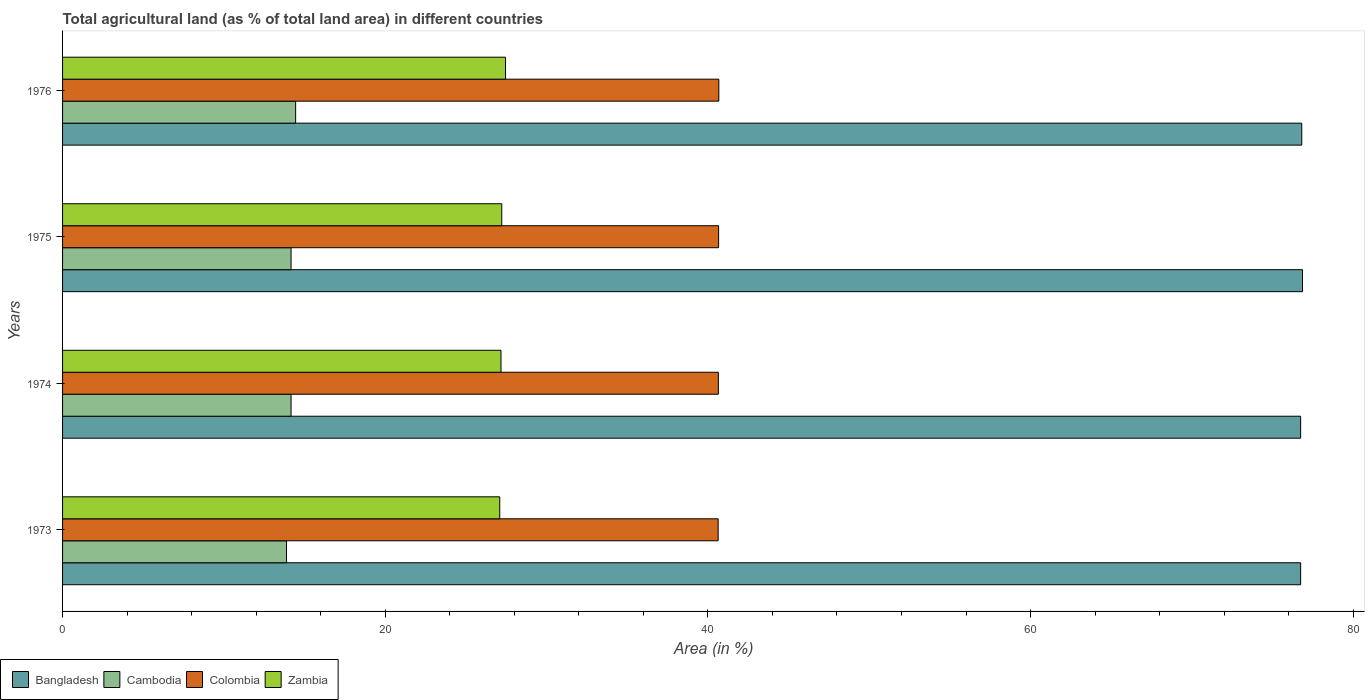Are the number of bars per tick equal to the number of legend labels?
Keep it short and to the point. Yes. What is the label of the 1st group of bars from the top?
Give a very brief answer. 1976. What is the percentage of agricultural land in Bangladesh in 1973?
Offer a very short reply. 76.74. Across all years, what is the maximum percentage of agricultural land in Cambodia?
Your answer should be compact. 14.45. Across all years, what is the minimum percentage of agricultural land in Zambia?
Provide a succinct answer. 27.1. In which year was the percentage of agricultural land in Bangladesh maximum?
Your answer should be compact. 1975. In which year was the percentage of agricultural land in Colombia minimum?
Your answer should be very brief. 1973. What is the total percentage of agricultural land in Zambia in the graph?
Provide a succinct answer. 108.95. What is the difference between the percentage of agricultural land in Cambodia in 1975 and that in 1976?
Provide a succinct answer. -0.28. What is the difference between the percentage of agricultural land in Cambodia in 1976 and the percentage of agricultural land in Colombia in 1974?
Provide a short and direct response. -26.2. What is the average percentage of agricultural land in Colombia per year?
Provide a short and direct response. 40.66. In the year 1976, what is the difference between the percentage of agricultural land in Cambodia and percentage of agricultural land in Bangladesh?
Your response must be concise. -62.36. What is the ratio of the percentage of agricultural land in Zambia in 1973 to that in 1976?
Provide a short and direct response. 0.99. Is the percentage of agricultural land in Colombia in 1974 less than that in 1976?
Ensure brevity in your answer.  Yes. Is the difference between the percentage of agricultural land in Cambodia in 1973 and 1974 greater than the difference between the percentage of agricultural land in Bangladesh in 1973 and 1974?
Provide a short and direct response. No. What is the difference between the highest and the second highest percentage of agricultural land in Cambodia?
Offer a very short reply. 0.28. What is the difference between the highest and the lowest percentage of agricultural land in Bangladesh?
Make the answer very short. 0.12. In how many years, is the percentage of agricultural land in Zambia greater than the average percentage of agricultural land in Zambia taken over all years?
Provide a short and direct response. 1. Is it the case that in every year, the sum of the percentage of agricultural land in Cambodia and percentage of agricultural land in Zambia is greater than the sum of percentage of agricultural land in Colombia and percentage of agricultural land in Bangladesh?
Give a very brief answer. No. What does the 2nd bar from the bottom in 1974 represents?
Offer a very short reply. Cambodia. How many bars are there?
Make the answer very short. 16. Are the values on the major ticks of X-axis written in scientific E-notation?
Give a very brief answer. No. Does the graph contain grids?
Your answer should be compact. No. Where does the legend appear in the graph?
Provide a succinct answer. Bottom left. How many legend labels are there?
Offer a very short reply. 4. What is the title of the graph?
Provide a succinct answer. Total agricultural land (as % of total land area) in different countries. Does "Germany" appear as one of the legend labels in the graph?
Provide a succinct answer. No. What is the label or title of the X-axis?
Your response must be concise. Area (in %). What is the label or title of the Y-axis?
Offer a very short reply. Years. What is the Area (in %) in Bangladesh in 1973?
Ensure brevity in your answer.  76.74. What is the Area (in %) in Cambodia in 1973?
Provide a short and direct response. 13.88. What is the Area (in %) in Colombia in 1973?
Make the answer very short. 40.63. What is the Area (in %) in Zambia in 1973?
Your answer should be compact. 27.1. What is the Area (in %) in Bangladesh in 1974?
Your answer should be very brief. 76.74. What is the Area (in %) in Cambodia in 1974?
Keep it short and to the point. 14.16. What is the Area (in %) in Colombia in 1974?
Make the answer very short. 40.65. What is the Area (in %) of Zambia in 1974?
Your answer should be compact. 27.18. What is the Area (in %) in Bangladesh in 1975?
Offer a very short reply. 76.85. What is the Area (in %) of Cambodia in 1975?
Keep it short and to the point. 14.16. What is the Area (in %) of Colombia in 1975?
Ensure brevity in your answer.  40.66. What is the Area (in %) of Zambia in 1975?
Offer a terse response. 27.22. What is the Area (in %) in Bangladesh in 1976?
Provide a short and direct response. 76.81. What is the Area (in %) of Cambodia in 1976?
Offer a very short reply. 14.45. What is the Area (in %) of Colombia in 1976?
Offer a very short reply. 40.68. What is the Area (in %) of Zambia in 1976?
Make the answer very short. 27.46. Across all years, what is the maximum Area (in %) in Bangladesh?
Offer a very short reply. 76.85. Across all years, what is the maximum Area (in %) of Cambodia?
Your answer should be very brief. 14.45. Across all years, what is the maximum Area (in %) of Colombia?
Your answer should be compact. 40.68. Across all years, what is the maximum Area (in %) of Zambia?
Give a very brief answer. 27.46. Across all years, what is the minimum Area (in %) of Bangladesh?
Keep it short and to the point. 76.74. Across all years, what is the minimum Area (in %) of Cambodia?
Your answer should be compact. 13.88. Across all years, what is the minimum Area (in %) in Colombia?
Offer a very short reply. 40.63. Across all years, what is the minimum Area (in %) in Zambia?
Make the answer very short. 27.1. What is the total Area (in %) in Bangladesh in the graph?
Ensure brevity in your answer.  307.14. What is the total Area (in %) in Cambodia in the graph?
Your response must be concise. 56.65. What is the total Area (in %) of Colombia in the graph?
Ensure brevity in your answer.  162.62. What is the total Area (in %) in Zambia in the graph?
Offer a terse response. 108.95. What is the difference between the Area (in %) of Cambodia in 1973 and that in 1974?
Provide a short and direct response. -0.28. What is the difference between the Area (in %) in Colombia in 1973 and that in 1974?
Your answer should be very brief. -0.01. What is the difference between the Area (in %) in Zambia in 1973 and that in 1974?
Offer a very short reply. -0.08. What is the difference between the Area (in %) of Bangladesh in 1973 and that in 1975?
Offer a terse response. -0.12. What is the difference between the Area (in %) in Cambodia in 1973 and that in 1975?
Ensure brevity in your answer.  -0.28. What is the difference between the Area (in %) in Colombia in 1973 and that in 1975?
Provide a succinct answer. -0.03. What is the difference between the Area (in %) of Zambia in 1973 and that in 1975?
Your answer should be compact. -0.13. What is the difference between the Area (in %) of Bangladesh in 1973 and that in 1976?
Offer a terse response. -0.07. What is the difference between the Area (in %) in Cambodia in 1973 and that in 1976?
Ensure brevity in your answer.  -0.57. What is the difference between the Area (in %) of Colombia in 1973 and that in 1976?
Provide a succinct answer. -0.04. What is the difference between the Area (in %) in Zambia in 1973 and that in 1976?
Provide a short and direct response. -0.36. What is the difference between the Area (in %) in Bangladesh in 1974 and that in 1975?
Your response must be concise. -0.12. What is the difference between the Area (in %) in Cambodia in 1974 and that in 1975?
Keep it short and to the point. 0. What is the difference between the Area (in %) of Colombia in 1974 and that in 1975?
Offer a terse response. -0.01. What is the difference between the Area (in %) of Zambia in 1974 and that in 1975?
Offer a very short reply. -0.05. What is the difference between the Area (in %) of Bangladesh in 1974 and that in 1976?
Your answer should be compact. -0.07. What is the difference between the Area (in %) in Cambodia in 1974 and that in 1976?
Offer a terse response. -0.28. What is the difference between the Area (in %) in Colombia in 1974 and that in 1976?
Offer a very short reply. -0.03. What is the difference between the Area (in %) in Zambia in 1974 and that in 1976?
Make the answer very short. -0.28. What is the difference between the Area (in %) of Bangladesh in 1975 and that in 1976?
Make the answer very short. 0.05. What is the difference between the Area (in %) of Cambodia in 1975 and that in 1976?
Your answer should be compact. -0.28. What is the difference between the Area (in %) in Colombia in 1975 and that in 1976?
Your answer should be very brief. -0.01. What is the difference between the Area (in %) of Zambia in 1975 and that in 1976?
Your answer should be compact. -0.23. What is the difference between the Area (in %) of Bangladesh in 1973 and the Area (in %) of Cambodia in 1974?
Your response must be concise. 62.58. What is the difference between the Area (in %) of Bangladesh in 1973 and the Area (in %) of Colombia in 1974?
Provide a succinct answer. 36.09. What is the difference between the Area (in %) in Bangladesh in 1973 and the Area (in %) in Zambia in 1974?
Your answer should be very brief. 49.56. What is the difference between the Area (in %) in Cambodia in 1973 and the Area (in %) in Colombia in 1974?
Provide a succinct answer. -26.77. What is the difference between the Area (in %) of Cambodia in 1973 and the Area (in %) of Zambia in 1974?
Keep it short and to the point. -13.3. What is the difference between the Area (in %) in Colombia in 1973 and the Area (in %) in Zambia in 1974?
Provide a short and direct response. 13.46. What is the difference between the Area (in %) in Bangladesh in 1973 and the Area (in %) in Cambodia in 1975?
Make the answer very short. 62.58. What is the difference between the Area (in %) in Bangladesh in 1973 and the Area (in %) in Colombia in 1975?
Provide a short and direct response. 36.08. What is the difference between the Area (in %) of Bangladesh in 1973 and the Area (in %) of Zambia in 1975?
Ensure brevity in your answer.  49.52. What is the difference between the Area (in %) of Cambodia in 1973 and the Area (in %) of Colombia in 1975?
Make the answer very short. -26.78. What is the difference between the Area (in %) of Cambodia in 1973 and the Area (in %) of Zambia in 1975?
Your answer should be very brief. -13.34. What is the difference between the Area (in %) of Colombia in 1973 and the Area (in %) of Zambia in 1975?
Make the answer very short. 13.41. What is the difference between the Area (in %) in Bangladesh in 1973 and the Area (in %) in Cambodia in 1976?
Give a very brief answer. 62.29. What is the difference between the Area (in %) in Bangladesh in 1973 and the Area (in %) in Colombia in 1976?
Provide a short and direct response. 36.06. What is the difference between the Area (in %) in Bangladesh in 1973 and the Area (in %) in Zambia in 1976?
Keep it short and to the point. 49.28. What is the difference between the Area (in %) of Cambodia in 1973 and the Area (in %) of Colombia in 1976?
Your answer should be very brief. -26.8. What is the difference between the Area (in %) of Cambodia in 1973 and the Area (in %) of Zambia in 1976?
Give a very brief answer. -13.58. What is the difference between the Area (in %) of Colombia in 1973 and the Area (in %) of Zambia in 1976?
Provide a short and direct response. 13.18. What is the difference between the Area (in %) of Bangladesh in 1974 and the Area (in %) of Cambodia in 1975?
Offer a terse response. 62.58. What is the difference between the Area (in %) of Bangladesh in 1974 and the Area (in %) of Colombia in 1975?
Your answer should be very brief. 36.08. What is the difference between the Area (in %) of Bangladesh in 1974 and the Area (in %) of Zambia in 1975?
Your answer should be very brief. 49.52. What is the difference between the Area (in %) in Cambodia in 1974 and the Area (in %) in Colombia in 1975?
Your answer should be compact. -26.5. What is the difference between the Area (in %) in Cambodia in 1974 and the Area (in %) in Zambia in 1975?
Your answer should be compact. -13.06. What is the difference between the Area (in %) in Colombia in 1974 and the Area (in %) in Zambia in 1975?
Your answer should be compact. 13.43. What is the difference between the Area (in %) in Bangladesh in 1974 and the Area (in %) in Cambodia in 1976?
Make the answer very short. 62.29. What is the difference between the Area (in %) in Bangladesh in 1974 and the Area (in %) in Colombia in 1976?
Your answer should be compact. 36.06. What is the difference between the Area (in %) of Bangladesh in 1974 and the Area (in %) of Zambia in 1976?
Give a very brief answer. 49.28. What is the difference between the Area (in %) of Cambodia in 1974 and the Area (in %) of Colombia in 1976?
Provide a succinct answer. -26.51. What is the difference between the Area (in %) of Cambodia in 1974 and the Area (in %) of Zambia in 1976?
Offer a very short reply. -13.29. What is the difference between the Area (in %) of Colombia in 1974 and the Area (in %) of Zambia in 1976?
Your response must be concise. 13.19. What is the difference between the Area (in %) in Bangladesh in 1975 and the Area (in %) in Cambodia in 1976?
Provide a short and direct response. 62.41. What is the difference between the Area (in %) of Bangladesh in 1975 and the Area (in %) of Colombia in 1976?
Offer a very short reply. 36.18. What is the difference between the Area (in %) of Bangladesh in 1975 and the Area (in %) of Zambia in 1976?
Your answer should be compact. 49.4. What is the difference between the Area (in %) of Cambodia in 1975 and the Area (in %) of Colombia in 1976?
Offer a very short reply. -26.51. What is the difference between the Area (in %) of Cambodia in 1975 and the Area (in %) of Zambia in 1976?
Provide a short and direct response. -13.29. What is the difference between the Area (in %) in Colombia in 1975 and the Area (in %) in Zambia in 1976?
Your response must be concise. 13.21. What is the average Area (in %) in Bangladesh per year?
Provide a succinct answer. 76.78. What is the average Area (in %) in Cambodia per year?
Your answer should be very brief. 14.16. What is the average Area (in %) in Colombia per year?
Provide a succinct answer. 40.66. What is the average Area (in %) in Zambia per year?
Ensure brevity in your answer.  27.24. In the year 1973, what is the difference between the Area (in %) of Bangladesh and Area (in %) of Cambodia?
Make the answer very short. 62.86. In the year 1973, what is the difference between the Area (in %) in Bangladesh and Area (in %) in Colombia?
Give a very brief answer. 36.1. In the year 1973, what is the difference between the Area (in %) of Bangladesh and Area (in %) of Zambia?
Provide a succinct answer. 49.64. In the year 1973, what is the difference between the Area (in %) in Cambodia and Area (in %) in Colombia?
Your answer should be compact. -26.76. In the year 1973, what is the difference between the Area (in %) of Cambodia and Area (in %) of Zambia?
Offer a very short reply. -13.22. In the year 1973, what is the difference between the Area (in %) of Colombia and Area (in %) of Zambia?
Keep it short and to the point. 13.54. In the year 1974, what is the difference between the Area (in %) in Bangladesh and Area (in %) in Cambodia?
Provide a succinct answer. 62.58. In the year 1974, what is the difference between the Area (in %) in Bangladesh and Area (in %) in Colombia?
Ensure brevity in your answer.  36.09. In the year 1974, what is the difference between the Area (in %) in Bangladesh and Area (in %) in Zambia?
Your answer should be compact. 49.56. In the year 1974, what is the difference between the Area (in %) of Cambodia and Area (in %) of Colombia?
Provide a short and direct response. -26.49. In the year 1974, what is the difference between the Area (in %) of Cambodia and Area (in %) of Zambia?
Offer a very short reply. -13.01. In the year 1974, what is the difference between the Area (in %) of Colombia and Area (in %) of Zambia?
Keep it short and to the point. 13.47. In the year 1975, what is the difference between the Area (in %) in Bangladesh and Area (in %) in Cambodia?
Give a very brief answer. 62.69. In the year 1975, what is the difference between the Area (in %) of Bangladesh and Area (in %) of Colombia?
Provide a short and direct response. 36.19. In the year 1975, what is the difference between the Area (in %) in Bangladesh and Area (in %) in Zambia?
Your response must be concise. 49.63. In the year 1975, what is the difference between the Area (in %) of Cambodia and Area (in %) of Colombia?
Offer a very short reply. -26.5. In the year 1975, what is the difference between the Area (in %) of Cambodia and Area (in %) of Zambia?
Ensure brevity in your answer.  -13.06. In the year 1975, what is the difference between the Area (in %) in Colombia and Area (in %) in Zambia?
Offer a very short reply. 13.44. In the year 1976, what is the difference between the Area (in %) in Bangladesh and Area (in %) in Cambodia?
Your answer should be compact. 62.36. In the year 1976, what is the difference between the Area (in %) of Bangladesh and Area (in %) of Colombia?
Offer a very short reply. 36.13. In the year 1976, what is the difference between the Area (in %) of Bangladesh and Area (in %) of Zambia?
Offer a very short reply. 49.35. In the year 1976, what is the difference between the Area (in %) of Cambodia and Area (in %) of Colombia?
Your response must be concise. -26.23. In the year 1976, what is the difference between the Area (in %) in Cambodia and Area (in %) in Zambia?
Offer a very short reply. -13.01. In the year 1976, what is the difference between the Area (in %) of Colombia and Area (in %) of Zambia?
Your answer should be compact. 13.22. What is the ratio of the Area (in %) of Bangladesh in 1973 to that in 1974?
Make the answer very short. 1. What is the ratio of the Area (in %) in Zambia in 1973 to that in 1974?
Provide a succinct answer. 1. What is the ratio of the Area (in %) of Cambodia in 1973 to that in 1975?
Give a very brief answer. 0.98. What is the ratio of the Area (in %) in Zambia in 1973 to that in 1975?
Your answer should be compact. 1. What is the ratio of the Area (in %) of Bangladesh in 1973 to that in 1976?
Offer a terse response. 1. What is the ratio of the Area (in %) of Cambodia in 1973 to that in 1976?
Make the answer very short. 0.96. What is the ratio of the Area (in %) of Colombia in 1973 to that in 1976?
Make the answer very short. 1. What is the ratio of the Area (in %) in Bangladesh in 1974 to that in 1975?
Give a very brief answer. 1. What is the ratio of the Area (in %) of Zambia in 1974 to that in 1975?
Your answer should be very brief. 1. What is the ratio of the Area (in %) in Cambodia in 1974 to that in 1976?
Your answer should be very brief. 0.98. What is the ratio of the Area (in %) in Colombia in 1974 to that in 1976?
Provide a succinct answer. 1. What is the ratio of the Area (in %) in Bangladesh in 1975 to that in 1976?
Your response must be concise. 1. What is the ratio of the Area (in %) in Cambodia in 1975 to that in 1976?
Your answer should be very brief. 0.98. What is the ratio of the Area (in %) in Colombia in 1975 to that in 1976?
Offer a terse response. 1. What is the ratio of the Area (in %) of Zambia in 1975 to that in 1976?
Offer a very short reply. 0.99. What is the difference between the highest and the second highest Area (in %) of Bangladesh?
Keep it short and to the point. 0.05. What is the difference between the highest and the second highest Area (in %) in Cambodia?
Provide a short and direct response. 0.28. What is the difference between the highest and the second highest Area (in %) in Colombia?
Make the answer very short. 0.01. What is the difference between the highest and the second highest Area (in %) of Zambia?
Offer a very short reply. 0.23. What is the difference between the highest and the lowest Area (in %) in Bangladesh?
Provide a succinct answer. 0.12. What is the difference between the highest and the lowest Area (in %) of Cambodia?
Offer a terse response. 0.57. What is the difference between the highest and the lowest Area (in %) in Colombia?
Give a very brief answer. 0.04. What is the difference between the highest and the lowest Area (in %) of Zambia?
Your response must be concise. 0.36. 